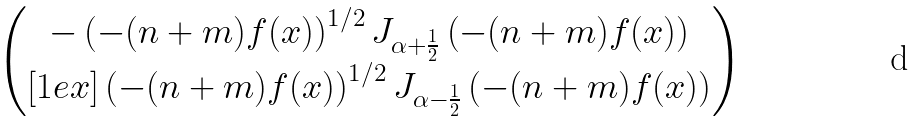Convert formula to latex. <formula><loc_0><loc_0><loc_500><loc_500>\begin{pmatrix} - \left ( - ( n + m ) f ( x ) \right ) ^ { 1 / 2 } J _ { \alpha + \frac { 1 } { 2 } } \left ( - ( n + m ) f ( x ) \right ) \\ [ 1 e x ] \left ( - ( n + m ) f ( x ) \right ) ^ { 1 / 2 } J _ { \alpha - \frac { 1 } { 2 } } \left ( - ( n + m ) f ( x ) \right ) \end{pmatrix}</formula> 